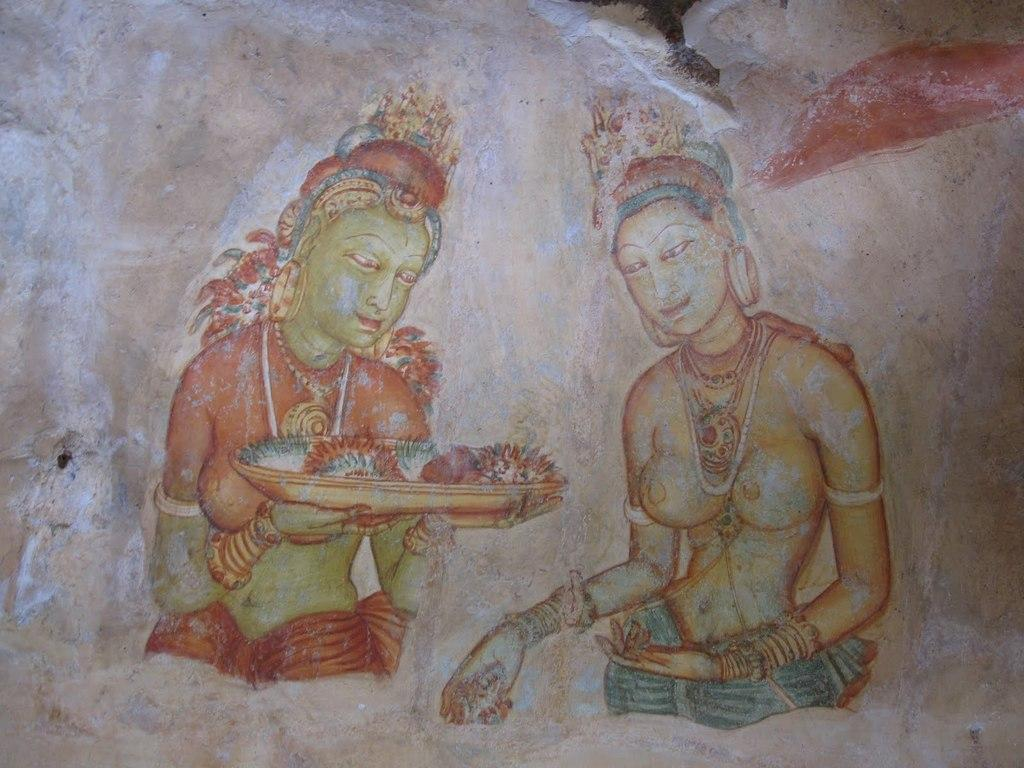What type of artwork is depicted in the image? The image is a painting. How many people are in the painting? There are two ladies in the painting. What is one of the ladies holding? One of the ladies is holding a plate. What is on the plate that the lady is holding? The plate contains flowers. What type of insurance policy do the ladies in the painting have? There is no information about insurance policies in the painting, as it depicts two ladies and a plate of flowers. 